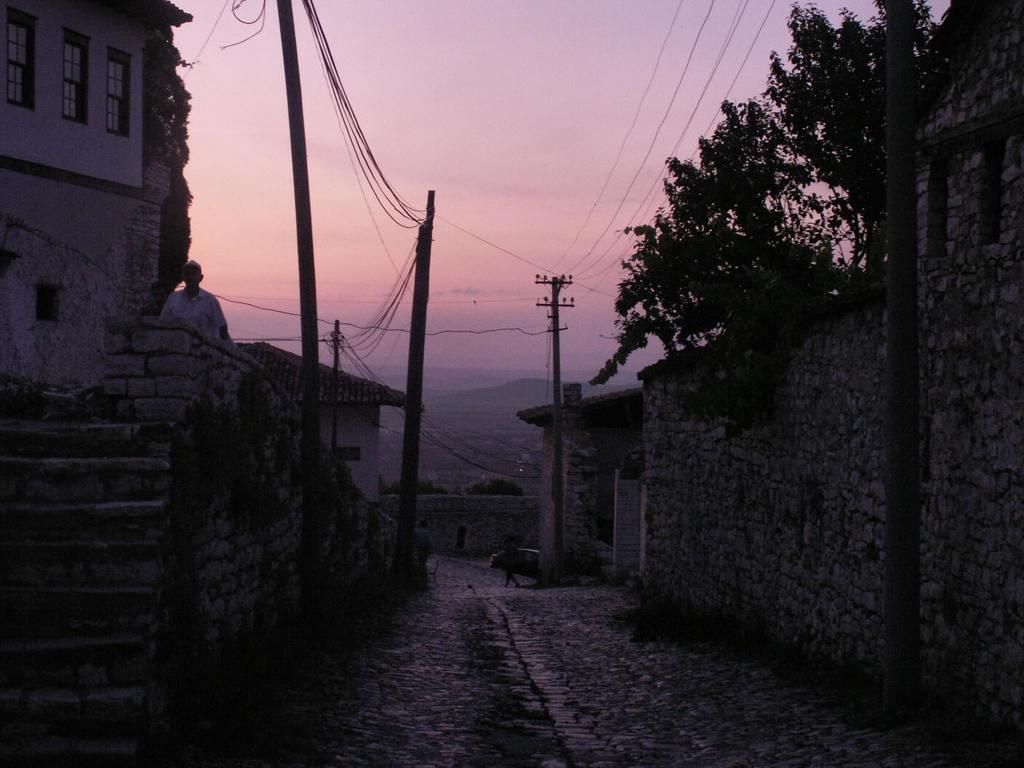What type of structures can be seen in the image? There are buildings in the image. What architectural feature is present in the image? There are stairs in the image. What type of vegetation is visible in the image? There are trees in the image. Where is the person located in the image? The person is on the left side of the image. What can be seen in the background of the image? There are poles with wires in the background of the image. What type of living creature is visible in the image? There is an animal visible in the image. What type of vest is the wind wearing in the image? There is no wind or vest present in the image. How many fangs does the animal have in the image? There is no mention of fangs or any specific animal in the image, so it is impossible to determine the number of fangs. 